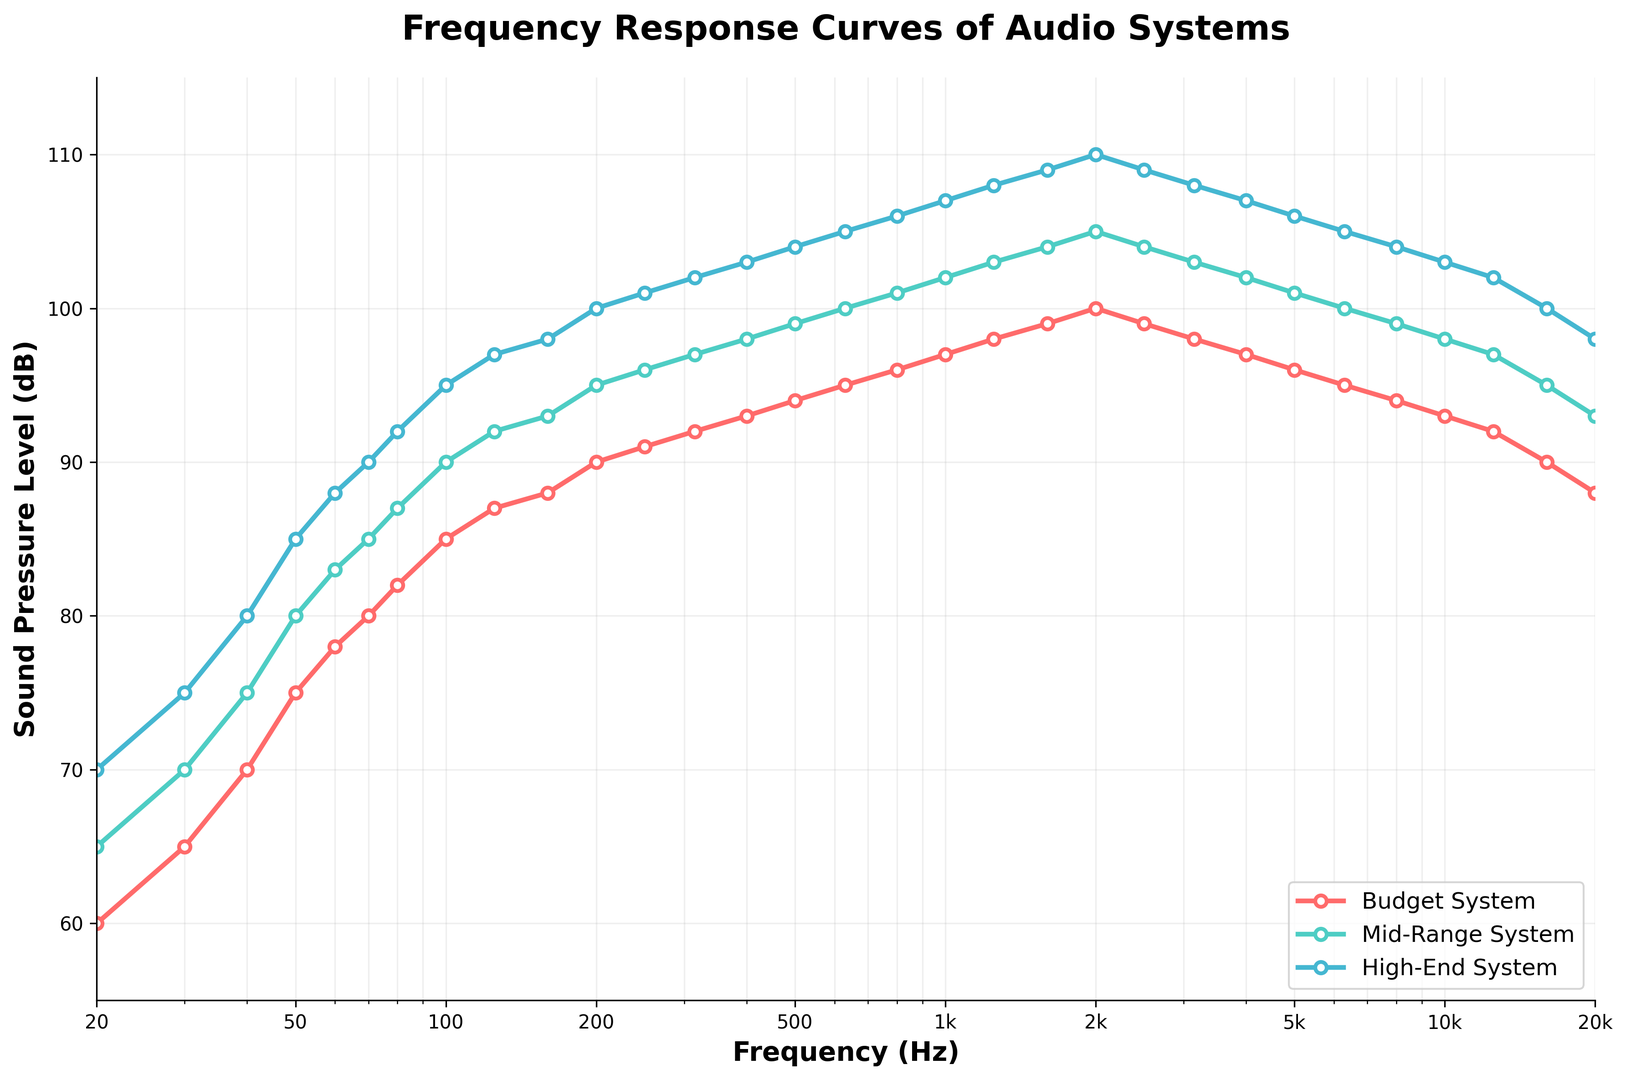What system has the highest sound pressure level at 1000 Hz? At 1000 Hz, the High-End System has a sound pressure level of 107 dB, which is higher than both the Budget System (97 dB) and the Mid-Range System (102 dB).
Answer: High-End System What is the difference in decibels between the Mid-Range System and Budget System at 500 Hz? At 500 Hz, the Mid-Range System has a level of 99 dB, and the Budget System has a level of 94 dB. The difference is 99 dB - 94 dB = 5 dB.
Answer: 5 dB At what frequency does the Budget System achieve a sound pressure level of 75 dB? The Budget System achieves 75 dB at 50 Hz, as seen on the figure.
Answer: 50 Hz Which of the three systems shows the most consistent sound pressure level across the frequency range? The High-End System shows the most consistent sound pressure level as its curve is the smoothest and least variable across the frequency range.
Answer: High-End System At 100 Hz, how does the decibel level of the Mid-Range System compare to that of the High-End System? At 100 Hz, the Mid-Range System has a decibel level of 90 dB, while the High-End System has a decibel level of 95 dB. The Mid-Range System is 5 dB lower than the High-End System.
Answer: 5 dB lower Between 2000 Hz and 10000 Hz, which system shows the largest drop in sound pressure level? The High-End System shows the largest drop; it goes from 110 dB at 2000 Hz to 103 dB at 10000 Hz, a drop of 7 dB, compared to the other systems.
Answer: High-End System What is the average sound pressure level of the Budget System at 500 Hz, 1000 Hz, and 2000 Hz? The Sound Pressure Levels are 94 dB at 500 Hz, 97 dB at 1000 Hz, and 100 dB at 2000 Hz. Thus, the average is (94 + 97 + 100) / 3 = 97 dB.
Answer: 97 dB At what frequency range does the Mid-Range System have a higher sound pressure level than the Budget System but lower than the High-End System? Between 20 Hz to 16000 Hz, the Mid-Range System consistently has higher sound pressure than the Budget System and lower than the High-End System, following the pattern of a mid-tier product in terms of decibel levels.
Answer: 20 Hz to 16000 Hz What is the overall trend in the sound pressure levels as the frequency increases for all systems? All three systems show an initial increase in sound pressure levels as the frequency increases up to about 2000 Hz. Afterward, the levels tend to stabilize and gradually decrease towards the higher frequency range (20,000 Hz).
Answer: Initial increase, then stabilization and gradual decrease If you sum the decibel levels of the High-End System at 125 Hz, 250 Hz, and 500 Hz, what do you get? The decibel levels of the High-End System at 125 Hz, 250 Hz, and 500 Hz are 97 dB, 101 dB, and 104 dB respectively. The sum is 97 + 101 + 104 = 302 dB.
Answer: 302 dB 